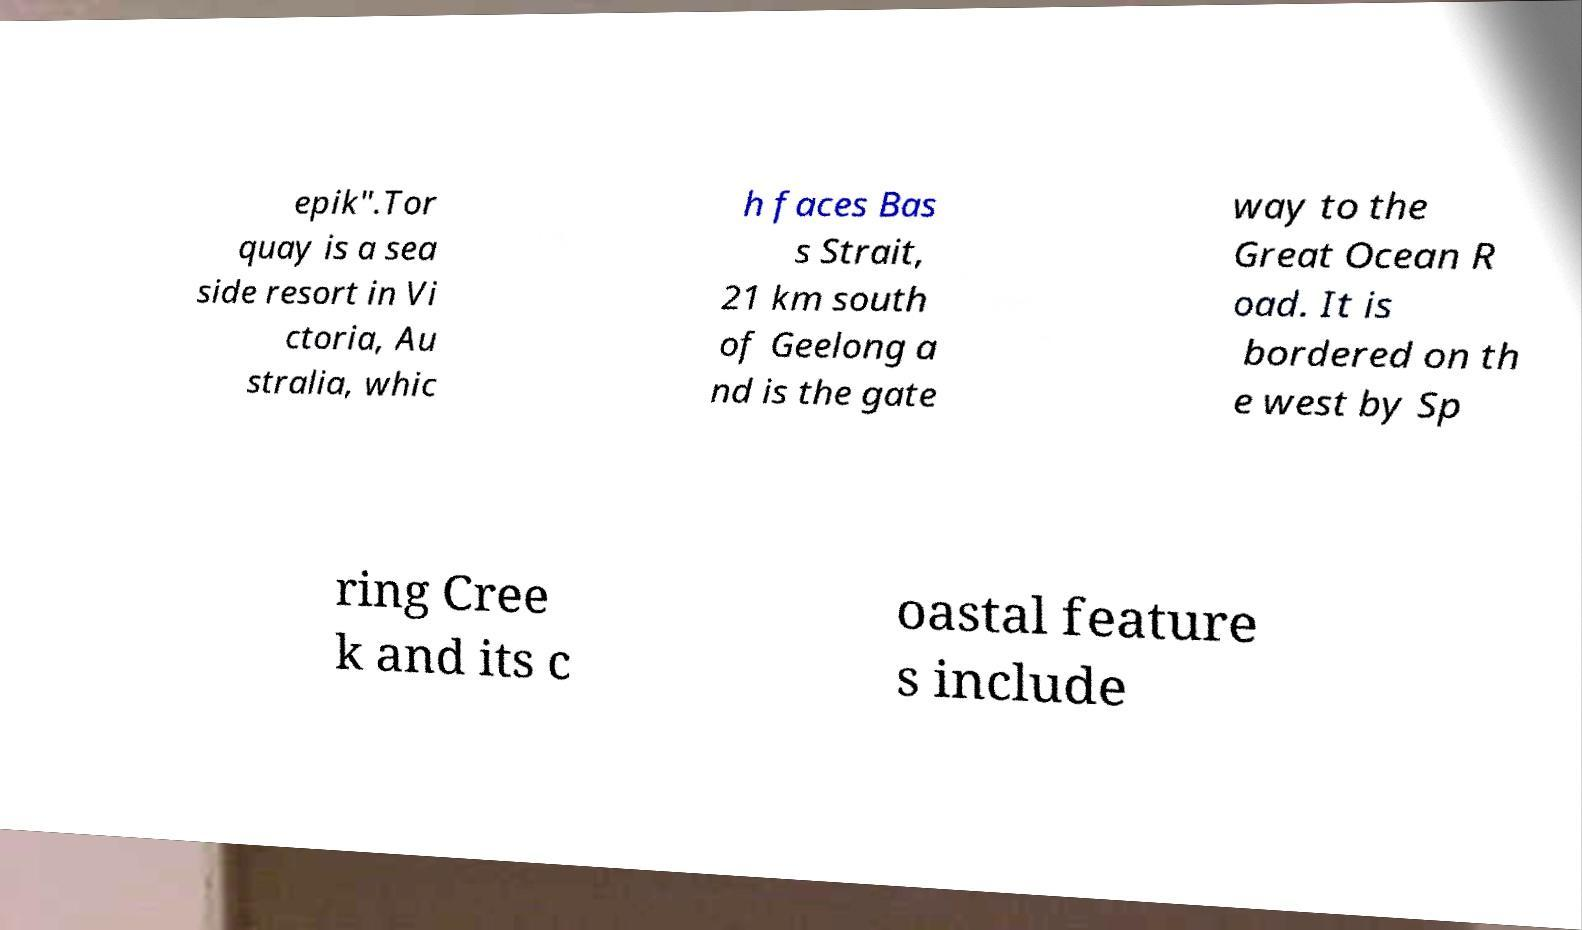Please read and relay the text visible in this image. What does it say? epik".Tor quay is a sea side resort in Vi ctoria, Au stralia, whic h faces Bas s Strait, 21 km south of Geelong a nd is the gate way to the Great Ocean R oad. It is bordered on th e west by Sp ring Cree k and its c oastal feature s include 